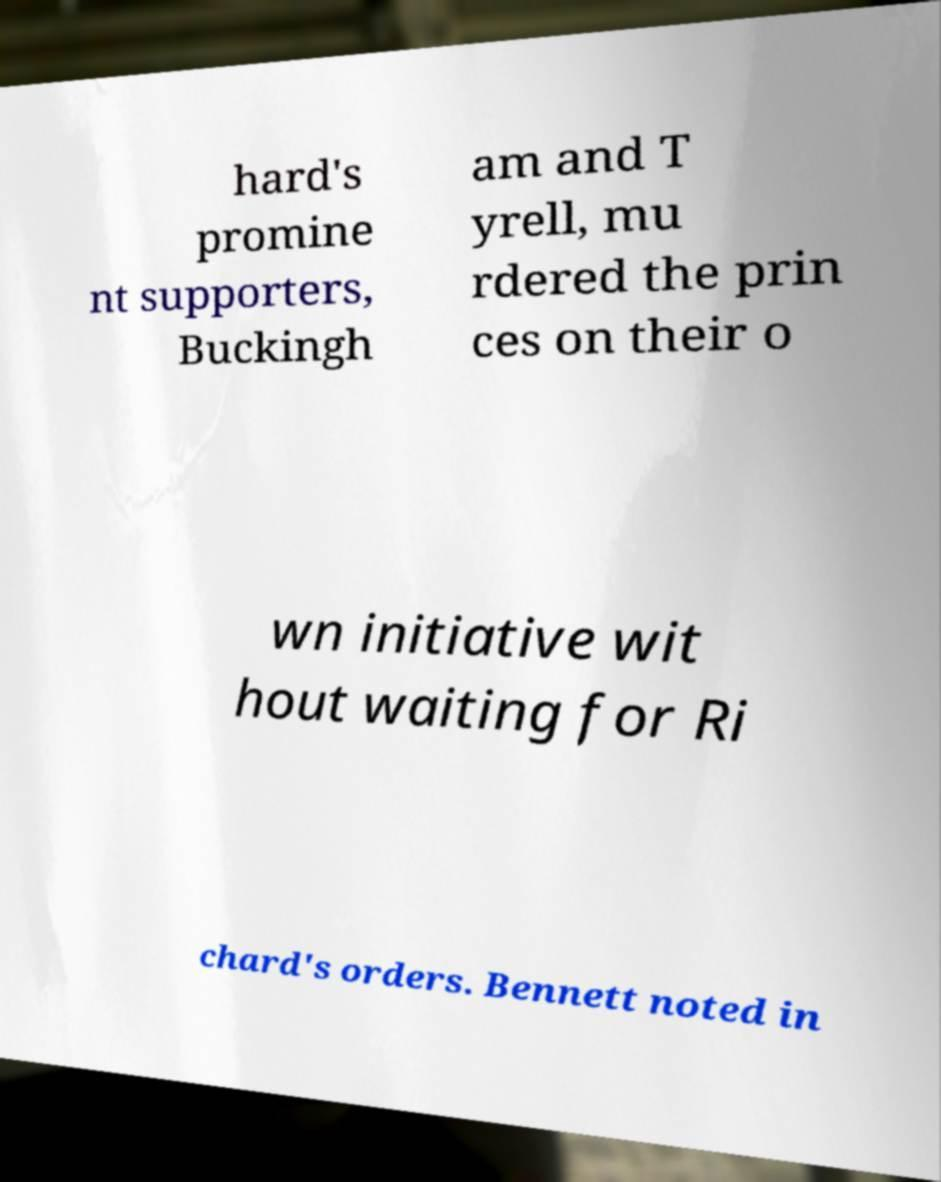Please read and relay the text visible in this image. What does it say? hard's promine nt supporters, Buckingh am and T yrell, mu rdered the prin ces on their o wn initiative wit hout waiting for Ri chard's orders. Bennett noted in 